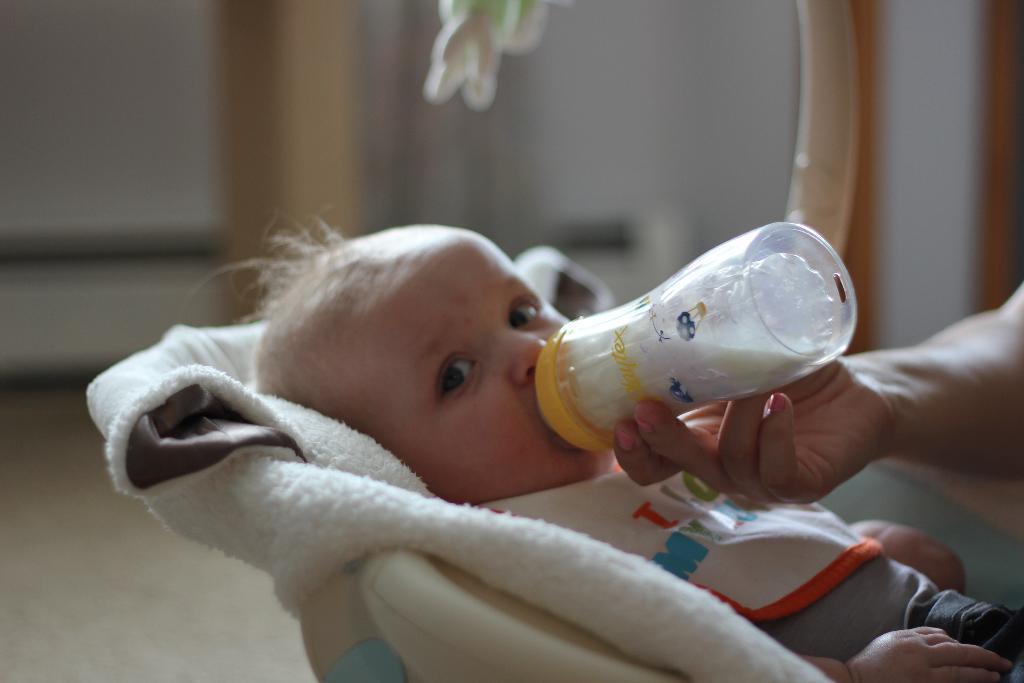Can you describe this image briefly? In this image i can see a baby she drinking a milk on the bottle. And a person hand is visible. And there is a cloth back side of the baby. 